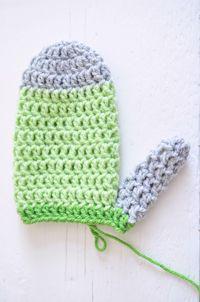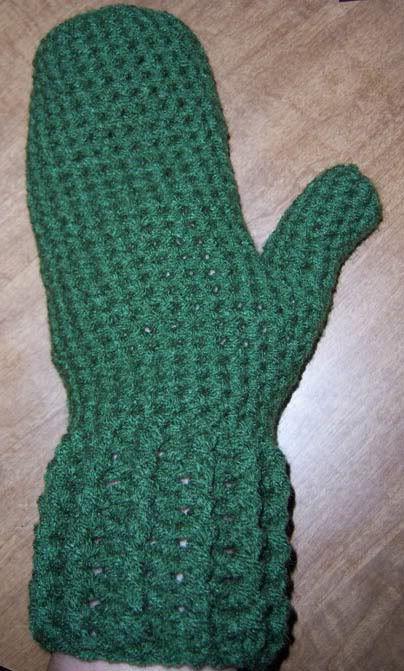The first image is the image on the left, the second image is the image on the right. Assess this claim about the two images: "There are no less than three mittens". Correct or not? Answer yes or no. No. 